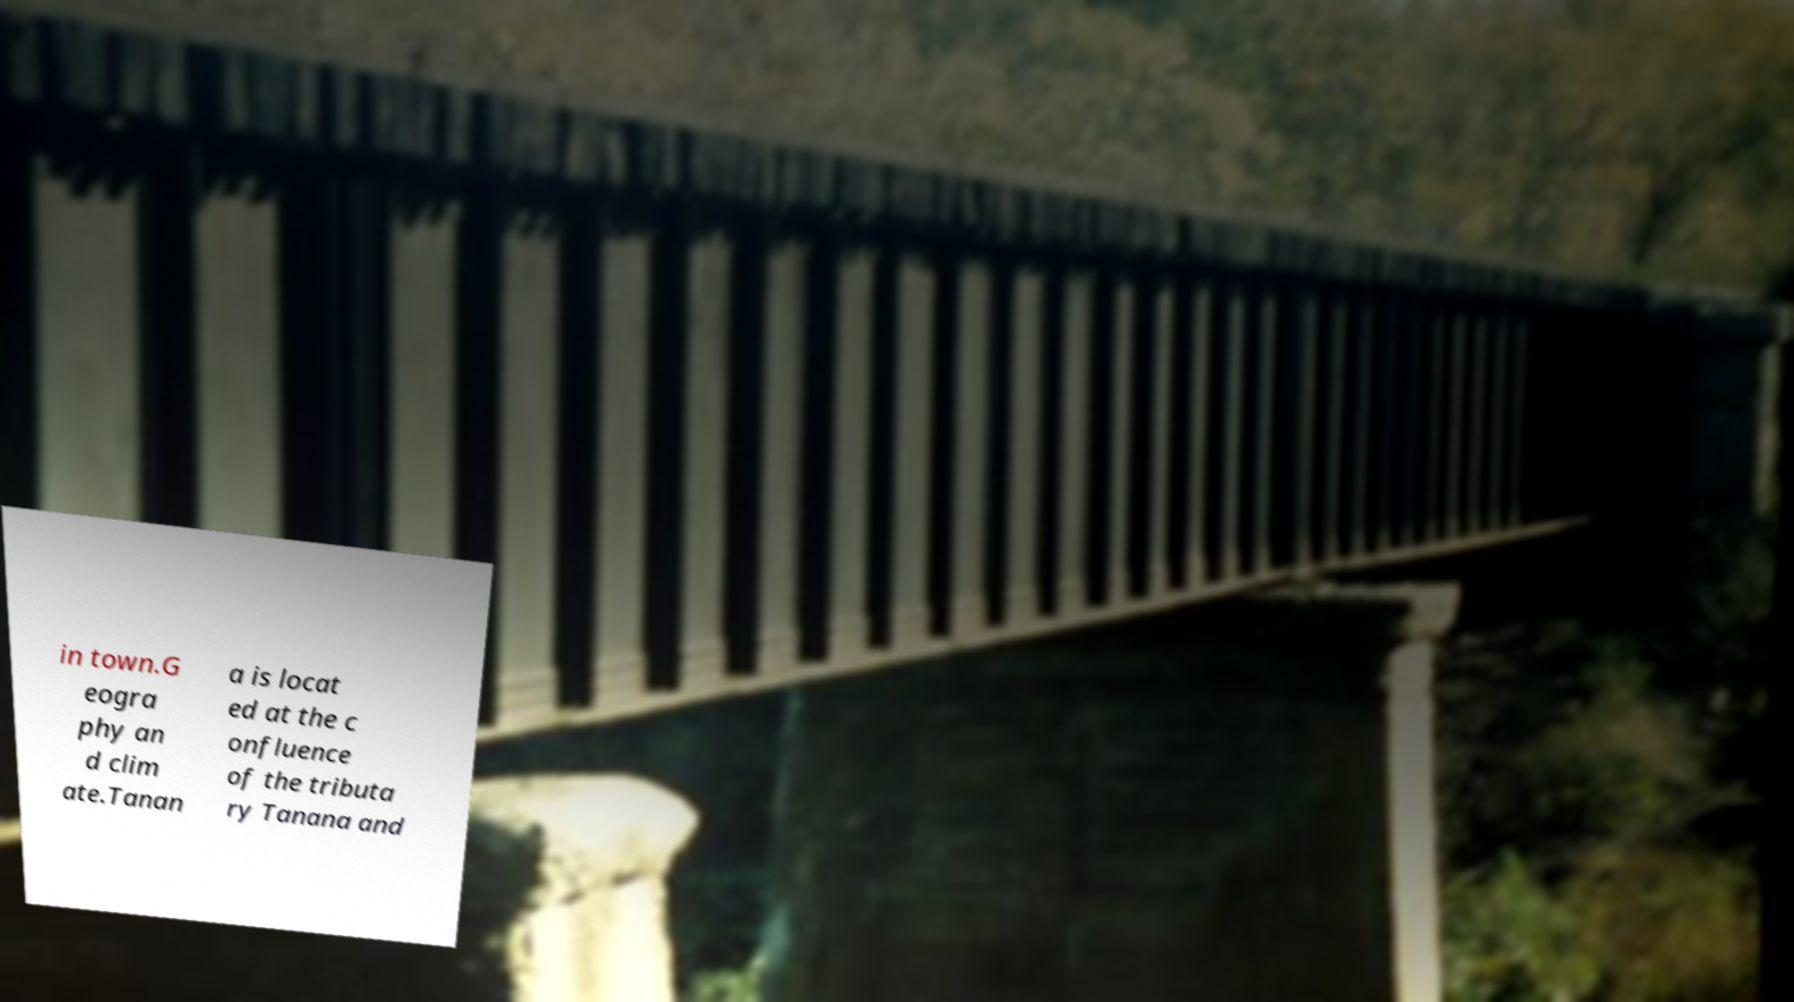I need the written content from this picture converted into text. Can you do that? in town.G eogra phy an d clim ate.Tanan a is locat ed at the c onfluence of the tributa ry Tanana and 